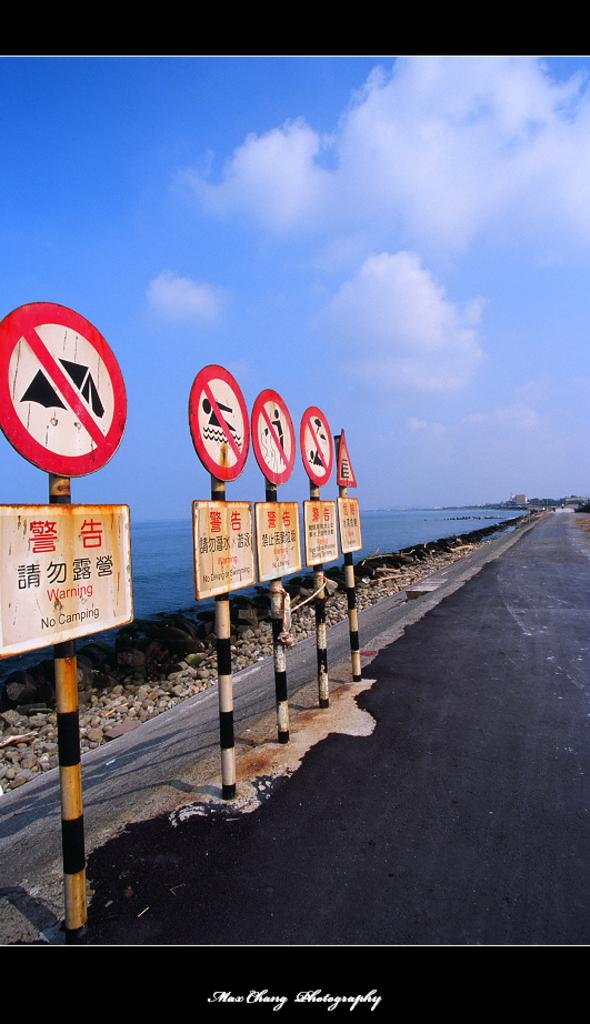<image>
Relay a brief, clear account of the picture shown. Five signs on a highway with one that says "WARNING NO CAMPING". 